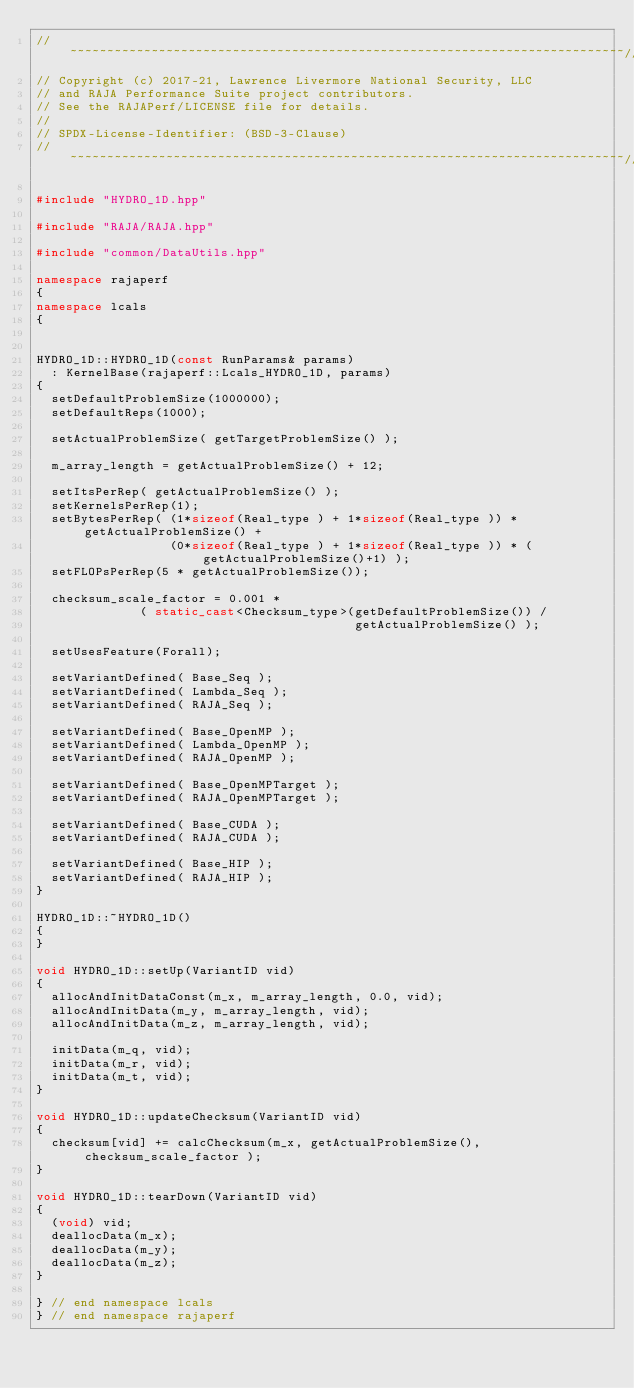Convert code to text. <code><loc_0><loc_0><loc_500><loc_500><_C++_>//~~~~~~~~~~~~~~~~~~~~~~~~~~~~~~~~~~~~~~~~~~~~~~~~~~~~~~~~~~~~~~~~~~~~~~~~~~~//
// Copyright (c) 2017-21, Lawrence Livermore National Security, LLC
// and RAJA Performance Suite project contributors.
// See the RAJAPerf/LICENSE file for details.
//
// SPDX-License-Identifier: (BSD-3-Clause)
//~~~~~~~~~~~~~~~~~~~~~~~~~~~~~~~~~~~~~~~~~~~~~~~~~~~~~~~~~~~~~~~~~~~~~~~~~~~//

#include "HYDRO_1D.hpp"

#include "RAJA/RAJA.hpp"

#include "common/DataUtils.hpp"

namespace rajaperf
{
namespace lcals
{


HYDRO_1D::HYDRO_1D(const RunParams& params)
  : KernelBase(rajaperf::Lcals_HYDRO_1D, params)
{
  setDefaultProblemSize(1000000);
  setDefaultReps(1000);

  setActualProblemSize( getTargetProblemSize() );

  m_array_length = getActualProblemSize() + 12;

  setItsPerRep( getActualProblemSize() );
  setKernelsPerRep(1);
  setBytesPerRep( (1*sizeof(Real_type ) + 1*sizeof(Real_type )) * getActualProblemSize() +
                  (0*sizeof(Real_type ) + 1*sizeof(Real_type )) * (getActualProblemSize()+1) );
  setFLOPsPerRep(5 * getActualProblemSize());

  checksum_scale_factor = 0.001 *
              ( static_cast<Checksum_type>(getDefaultProblemSize()) /
                                           getActualProblemSize() );

  setUsesFeature(Forall);

  setVariantDefined( Base_Seq );
  setVariantDefined( Lambda_Seq );
  setVariantDefined( RAJA_Seq );

  setVariantDefined( Base_OpenMP );
  setVariantDefined( Lambda_OpenMP );
  setVariantDefined( RAJA_OpenMP );

  setVariantDefined( Base_OpenMPTarget );
  setVariantDefined( RAJA_OpenMPTarget );

  setVariantDefined( Base_CUDA );
  setVariantDefined( RAJA_CUDA );

  setVariantDefined( Base_HIP );
  setVariantDefined( RAJA_HIP );
}

HYDRO_1D::~HYDRO_1D()
{
}

void HYDRO_1D::setUp(VariantID vid)
{
  allocAndInitDataConst(m_x, m_array_length, 0.0, vid);
  allocAndInitData(m_y, m_array_length, vid);
  allocAndInitData(m_z, m_array_length, vid);

  initData(m_q, vid);
  initData(m_r, vid);
  initData(m_t, vid);
}

void HYDRO_1D::updateChecksum(VariantID vid)
{
  checksum[vid] += calcChecksum(m_x, getActualProblemSize(), checksum_scale_factor );
}

void HYDRO_1D::tearDown(VariantID vid)
{
  (void) vid;
  deallocData(m_x);
  deallocData(m_y);
  deallocData(m_z);
}

} // end namespace lcals
} // end namespace rajaperf
</code> 